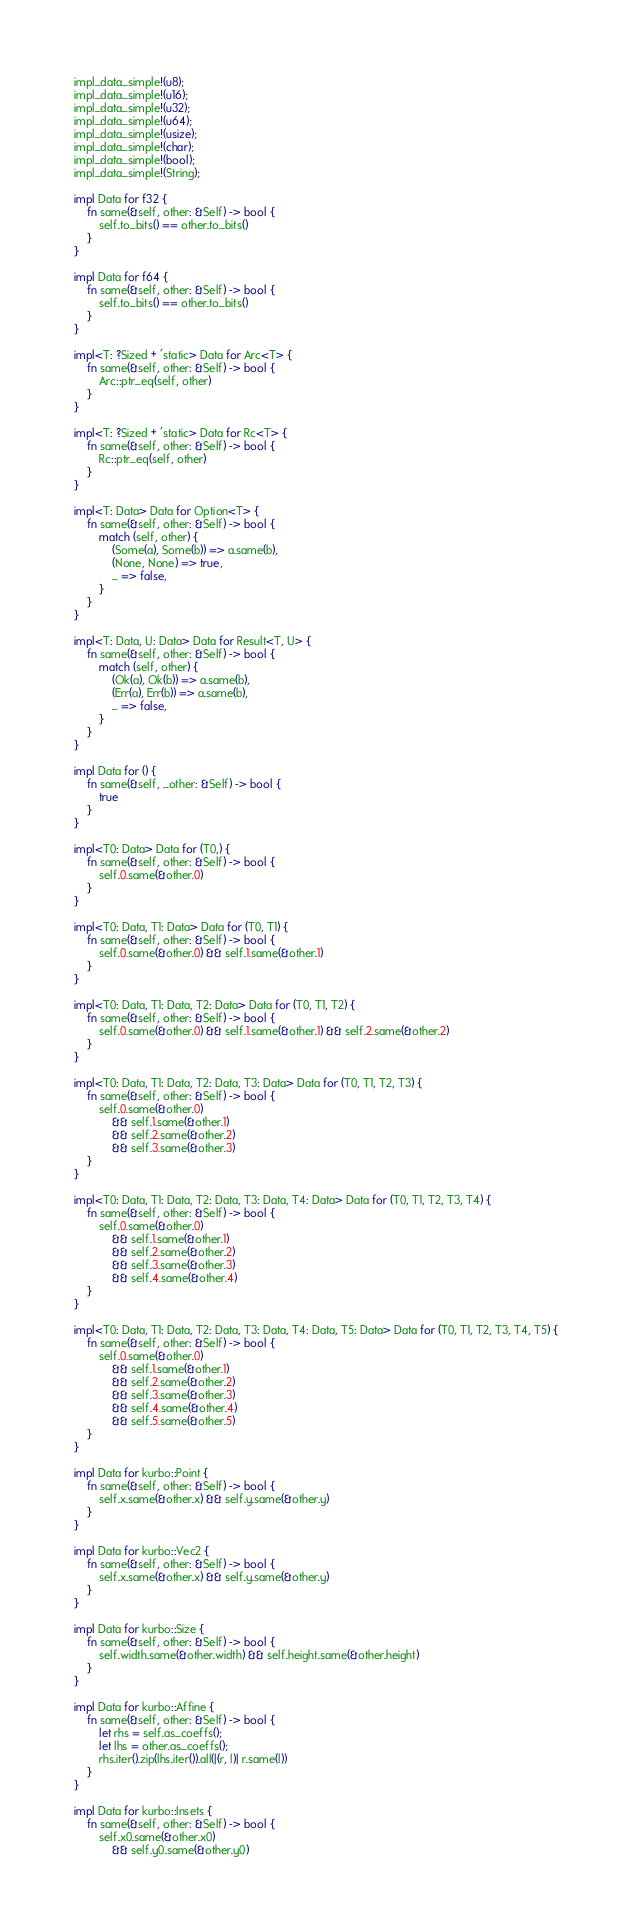<code> <loc_0><loc_0><loc_500><loc_500><_Rust_>impl_data_simple!(u8);
impl_data_simple!(u16);
impl_data_simple!(u32);
impl_data_simple!(u64);
impl_data_simple!(usize);
impl_data_simple!(char);
impl_data_simple!(bool);
impl_data_simple!(String);

impl Data for f32 {
    fn same(&self, other: &Self) -> bool {
        self.to_bits() == other.to_bits()
    }
}

impl Data for f64 {
    fn same(&self, other: &Self) -> bool {
        self.to_bits() == other.to_bits()
    }
}

impl<T: ?Sized + 'static> Data for Arc<T> {
    fn same(&self, other: &Self) -> bool {
        Arc::ptr_eq(self, other)
    }
}

impl<T: ?Sized + 'static> Data for Rc<T> {
    fn same(&self, other: &Self) -> bool {
        Rc::ptr_eq(self, other)
    }
}

impl<T: Data> Data for Option<T> {
    fn same(&self, other: &Self) -> bool {
        match (self, other) {
            (Some(a), Some(b)) => a.same(b),
            (None, None) => true,
            _ => false,
        }
    }
}

impl<T: Data, U: Data> Data for Result<T, U> {
    fn same(&self, other: &Self) -> bool {
        match (self, other) {
            (Ok(a), Ok(b)) => a.same(b),
            (Err(a), Err(b)) => a.same(b),
            _ => false,
        }
    }
}

impl Data for () {
    fn same(&self, _other: &Self) -> bool {
        true
    }
}

impl<T0: Data> Data for (T0,) {
    fn same(&self, other: &Self) -> bool {
        self.0.same(&other.0)
    }
}

impl<T0: Data, T1: Data> Data for (T0, T1) {
    fn same(&self, other: &Self) -> bool {
        self.0.same(&other.0) && self.1.same(&other.1)
    }
}

impl<T0: Data, T1: Data, T2: Data> Data for (T0, T1, T2) {
    fn same(&self, other: &Self) -> bool {
        self.0.same(&other.0) && self.1.same(&other.1) && self.2.same(&other.2)
    }
}

impl<T0: Data, T1: Data, T2: Data, T3: Data> Data for (T0, T1, T2, T3) {
    fn same(&self, other: &Self) -> bool {
        self.0.same(&other.0)
            && self.1.same(&other.1)
            && self.2.same(&other.2)
            && self.3.same(&other.3)
    }
}

impl<T0: Data, T1: Data, T2: Data, T3: Data, T4: Data> Data for (T0, T1, T2, T3, T4) {
    fn same(&self, other: &Self) -> bool {
        self.0.same(&other.0)
            && self.1.same(&other.1)
            && self.2.same(&other.2)
            && self.3.same(&other.3)
            && self.4.same(&other.4)
    }
}

impl<T0: Data, T1: Data, T2: Data, T3: Data, T4: Data, T5: Data> Data for (T0, T1, T2, T3, T4, T5) {
    fn same(&self, other: &Self) -> bool {
        self.0.same(&other.0)
            && self.1.same(&other.1)
            && self.2.same(&other.2)
            && self.3.same(&other.3)
            && self.4.same(&other.4)
            && self.5.same(&other.5)
    }
}

impl Data for kurbo::Point {
    fn same(&self, other: &Self) -> bool {
        self.x.same(&other.x) && self.y.same(&other.y)
    }
}

impl Data for kurbo::Vec2 {
    fn same(&self, other: &Self) -> bool {
        self.x.same(&other.x) && self.y.same(&other.y)
    }
}

impl Data for kurbo::Size {
    fn same(&self, other: &Self) -> bool {
        self.width.same(&other.width) && self.height.same(&other.height)
    }
}

impl Data for kurbo::Affine {
    fn same(&self, other: &Self) -> bool {
        let rhs = self.as_coeffs();
        let lhs = other.as_coeffs();
        rhs.iter().zip(lhs.iter()).all(|(r, l)| r.same(l))
    }
}

impl Data for kurbo::Insets {
    fn same(&self, other: &Self) -> bool {
        self.x0.same(&other.x0)
            && self.y0.same(&other.y0)</code> 